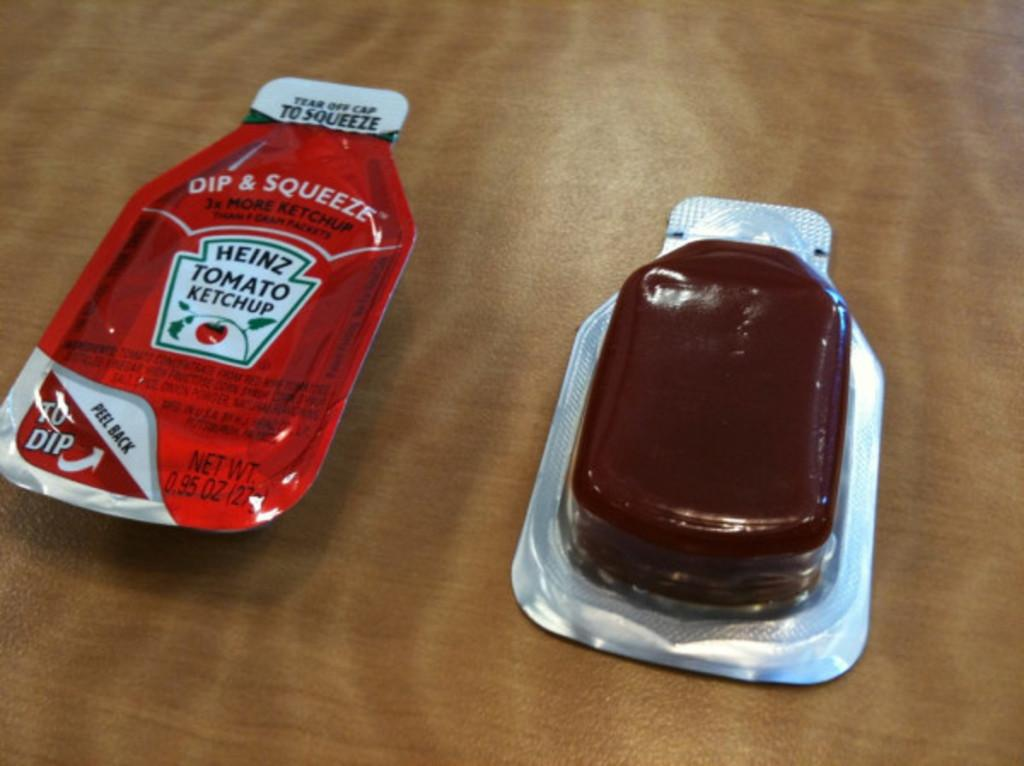<image>
Describe the image concisely. Two small packets of condiments, one is Heinz Ketchup and the other is flipped over and clear packaging so you can see the contents 